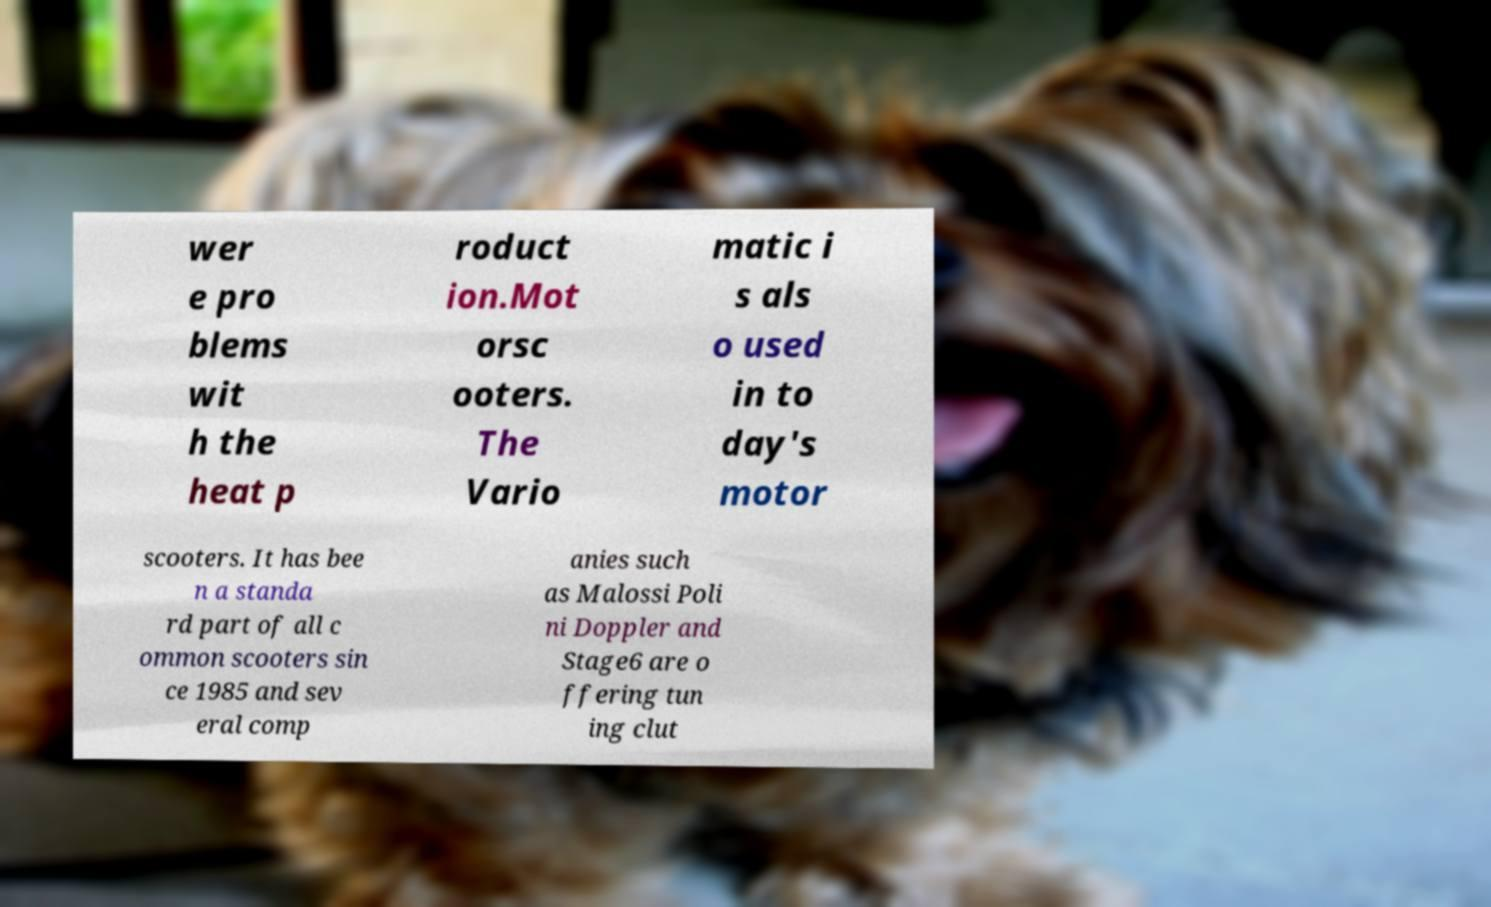Please identify and transcribe the text found in this image. wer e pro blems wit h the heat p roduct ion.Mot orsc ooters. The Vario matic i s als o used in to day's motor scooters. It has bee n a standa rd part of all c ommon scooters sin ce 1985 and sev eral comp anies such as Malossi Poli ni Doppler and Stage6 are o ffering tun ing clut 